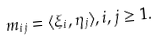Convert formula to latex. <formula><loc_0><loc_0><loc_500><loc_500>m _ { i j } = \langle \xi _ { i } , \eta _ { j } \rangle , i , j \geq 1 .</formula> 